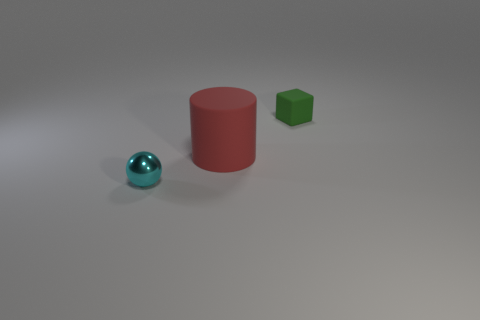How many other objects are the same size as the red matte cylinder? 0 